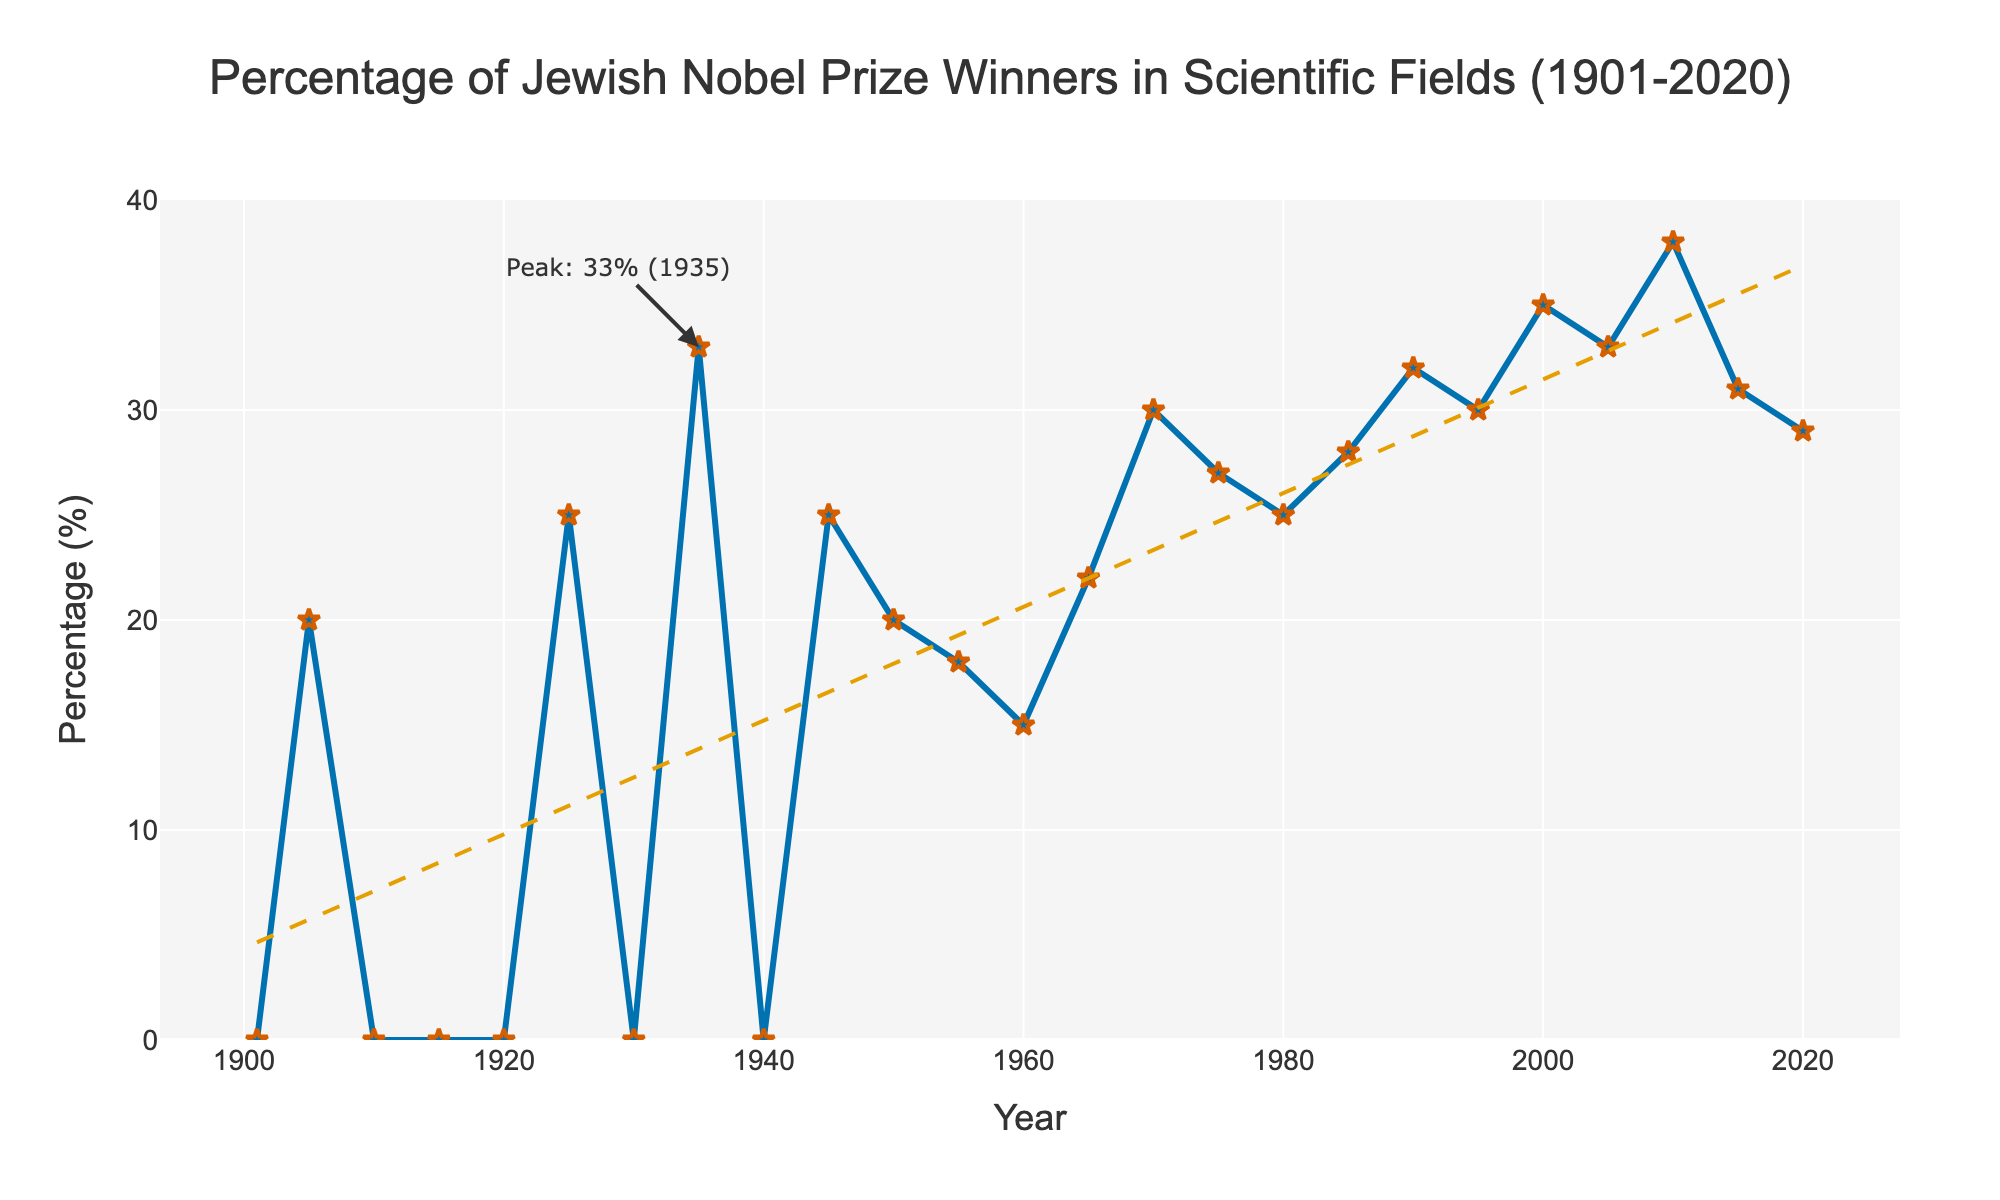What is the percentage of Jewish Nobel Prize winners in 1925? Refer to the data point for the year 1925 on the line chart, which shows 25%.
Answer: 25% During which year did the percentage of Jewish Nobel Prize winners peak and what was the percentage? Look at the annotation on the chart, which highlights the peak percentage of 33% in 1935.
Answer: 1935, 33% Compare the percentage of Jewish Nobel Prize winners in 1960 and 2000. Which year had the higher percentage? Refer to the data points for 1960 and 2000. In 1960, the percentage is 15%, and in 2000, it is 35%. Thus, the year 2000 had a higher percentage.
Answer: 2000 What is the average percentage of Jewish Nobel Prize winners from 1950 to 1970? Sum the percentages for 1950 (20%), 1955 (18%), 1960 (15%), 1965 (22%), and 1970 (30%), then divide by the number of years (5). The average is (20+18+15+22+30)/5 = 21%.
Answer: 21% How did the percentage change from 2005 to 2010? Subtract the percentage in 2005 (33%) from the percentage in 2010 (38%). The change is 38% - 33% = 5%.
Answer: Increased by 5% Which decade saw the most consistent percentage of Jewish Nobel Prize winners? Look at the progression of percentages over each decade. The 1950s had the following values: 1950 (20%), 1955 (18%), 1960 (15%). Variations in this decade are less than subsequent decades.
Answer: 1950s Identify a period where the percentage of Jewish Nobel Prize winners stayed at zero for consecutive years and specify the range. Check the periods with successive zero values; the range is from 1910 to 1920.
Answer: 1910-1920 What is the trend in the percentage of Jewish Nobel Prize winners from 1900 to 2020 based on the trend line? Refer to the dashed trend line in the chart, which generally shows an increasing trend from left to right.
Answer: Increasing Compare the percentages of Jewish Nobel Prize winners in 1935 and 2015. Has it increased or decreased? Refer to the data points for 1935 (33%) and 2015 (31%). The percentage decreased slightly.
Answer: Decreased Why does the period between 1910 and 1920 in the chart stand out? Identify the unusual pattern in that period, which is characterized by consecutive zero percentages.
Answer: It's notable for consecutive zero percentages 